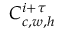<formula> <loc_0><loc_0><loc_500><loc_500>C _ { c , w , h } ^ { i + \tau }</formula> 